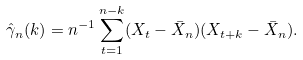Convert formula to latex. <formula><loc_0><loc_0><loc_500><loc_500>\hat { \gamma } _ { n } ( k ) = n ^ { - 1 } \sum _ { t = 1 } ^ { n - k } ( X _ { t } - \bar { X } _ { n } ) ( X _ { t + k } - \bar { X } _ { n } ) .</formula> 